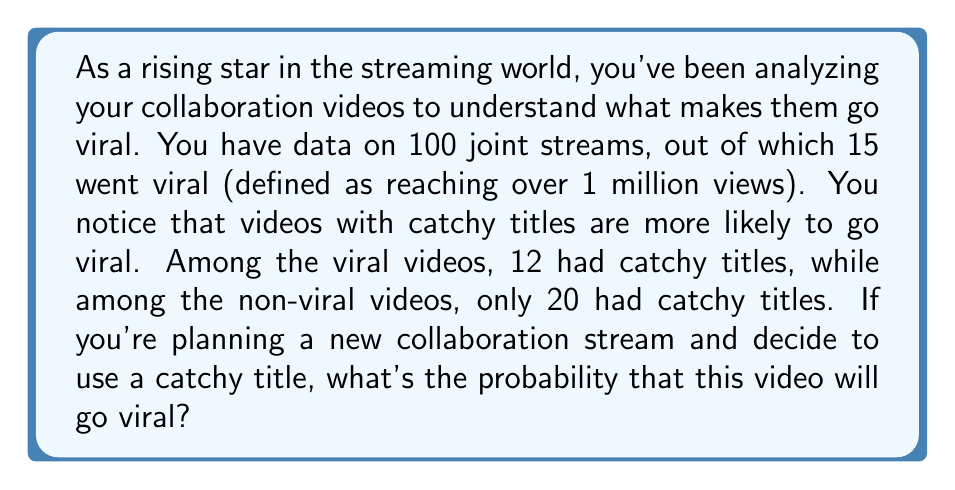Give your solution to this math problem. To solve this problem, we'll use Bayes' Theorem. Let's define our events:

$V$: The video goes viral
$C$: The video has a catchy title

We want to find $P(V|C)$, the probability that the video goes viral given that it has a catchy title.

Bayes' Theorem states:

$$P(V|C) = \frac{P(C|V) \cdot P(V)}{P(C)}$$

Let's calculate each component:

1) $P(V)$: The probability of a video going viral
   $P(V) = \frac{15}{100} = 0.15$

2) $P(C|V)$: The probability of a catchy title given the video is viral
   $P(C|V) = \frac{12}{15} = 0.8$

3) $P(C)$: The probability of a video having a catchy title
   Total catchy titles: $12 + 20 = 32$
   $P(C) = \frac{32}{100} = 0.32$

Now, let's plug these values into Bayes' Theorem:

$$P(V|C) = \frac{0.8 \cdot 0.15}{0.32} = \frac{0.12}{0.32} = 0.375$$

Therefore, the probability that a video with a catchy title will go viral is 0.375 or 37.5%.
Answer: $0.375$ or $37.5\%$ 